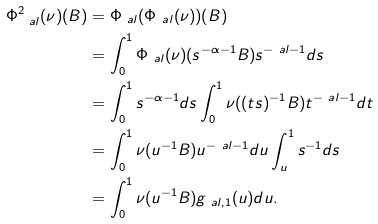<formula> <loc_0><loc_0><loc_500><loc_500>\Phi _ { \ a l } ^ { 2 } ( \nu ) ( B ) & = \Phi _ { \ a l } ( \Phi _ { \ a l } ( \nu ) ) ( B ) \\ & = \int _ { 0 } ^ { 1 } \Phi _ { \ a l } ( \nu ) ( s ^ { - \alpha - 1 } B ) s ^ { - \ a l - 1 } d s \\ & = \int _ { 0 } ^ { 1 } s ^ { - \alpha - 1 } d s \int _ { 0 } ^ { 1 } \nu ( ( t s ) ^ { - 1 } B ) t ^ { - \ a l - 1 } d t \\ & = \int _ { 0 } ^ { 1 } \nu ( u ^ { - 1 } B ) u ^ { - \ a l - 1 } d u \int _ { u } ^ { 1 } s ^ { - 1 } d s \\ & = \int _ { 0 } ^ { 1 } \nu ( u ^ { - 1 } B ) g _ { \ a l , 1 } ( u ) d u .</formula> 